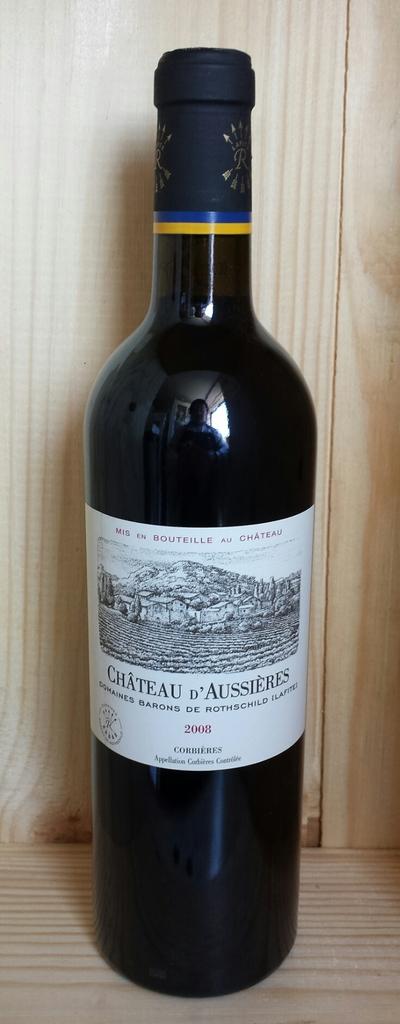What year was this wine bottled?
Your response must be concise. 2008. 